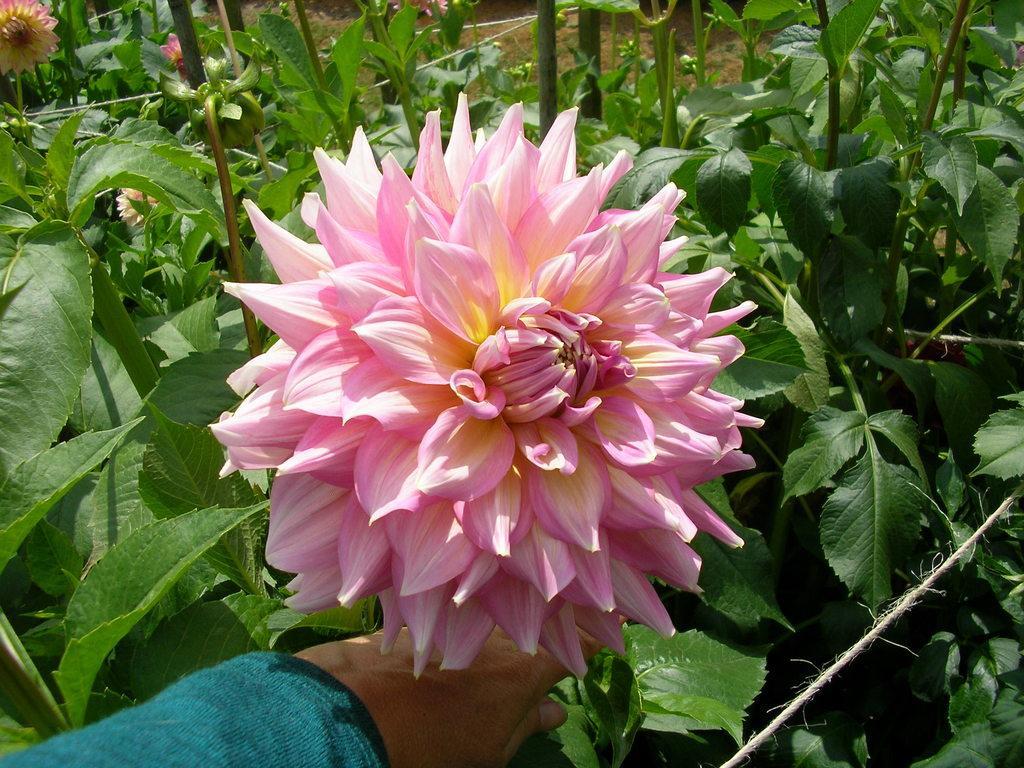Please provide a concise description of this image. In front of the image we can see the hand of a person. There are plants and flowers. 